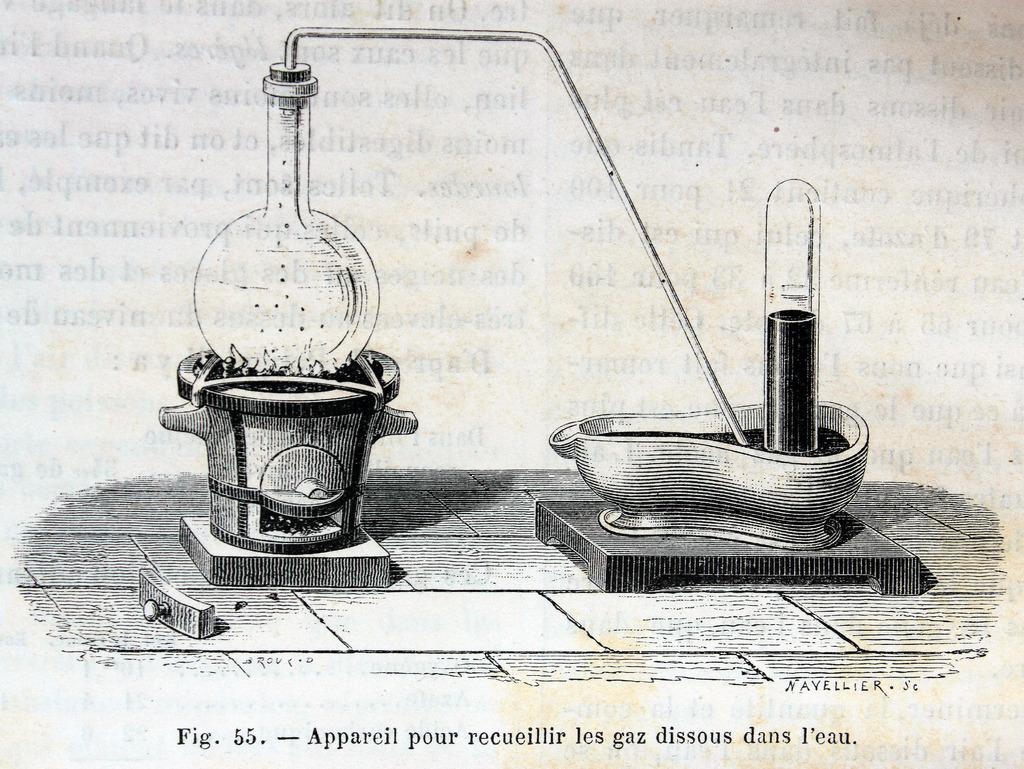<image>
Provide a brief description of the given image. An illustration from a book labeled figure 55. 